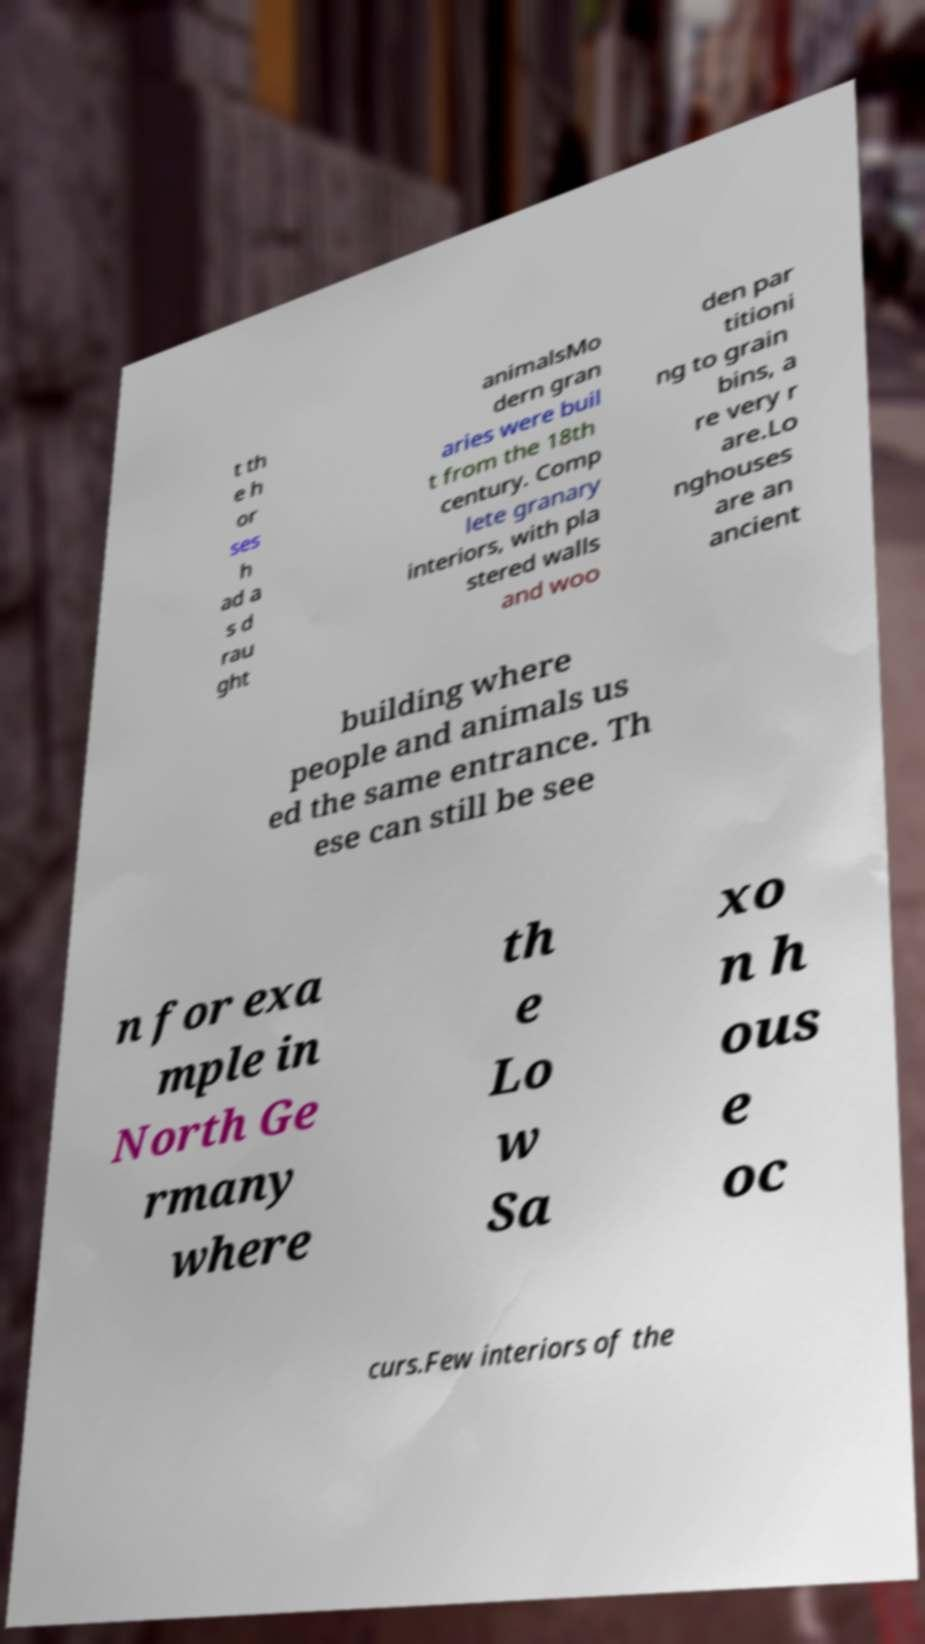Please identify and transcribe the text found in this image. t th e h or ses h ad a s d rau ght animalsMo dern gran aries were buil t from the 18th century. Comp lete granary interiors, with pla stered walls and woo den par titioni ng to grain bins, a re very r are.Lo nghouses are an ancient building where people and animals us ed the same entrance. Th ese can still be see n for exa mple in North Ge rmany where th e Lo w Sa xo n h ous e oc curs.Few interiors of the 